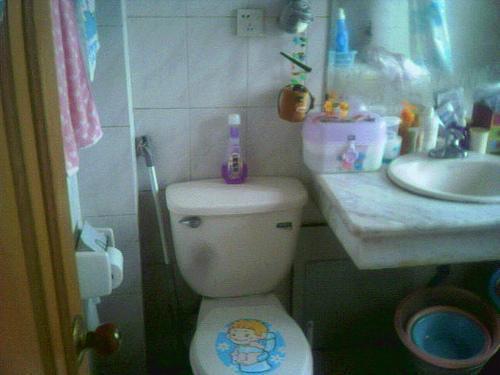How many sinks are there?
Give a very brief answer. 1. 